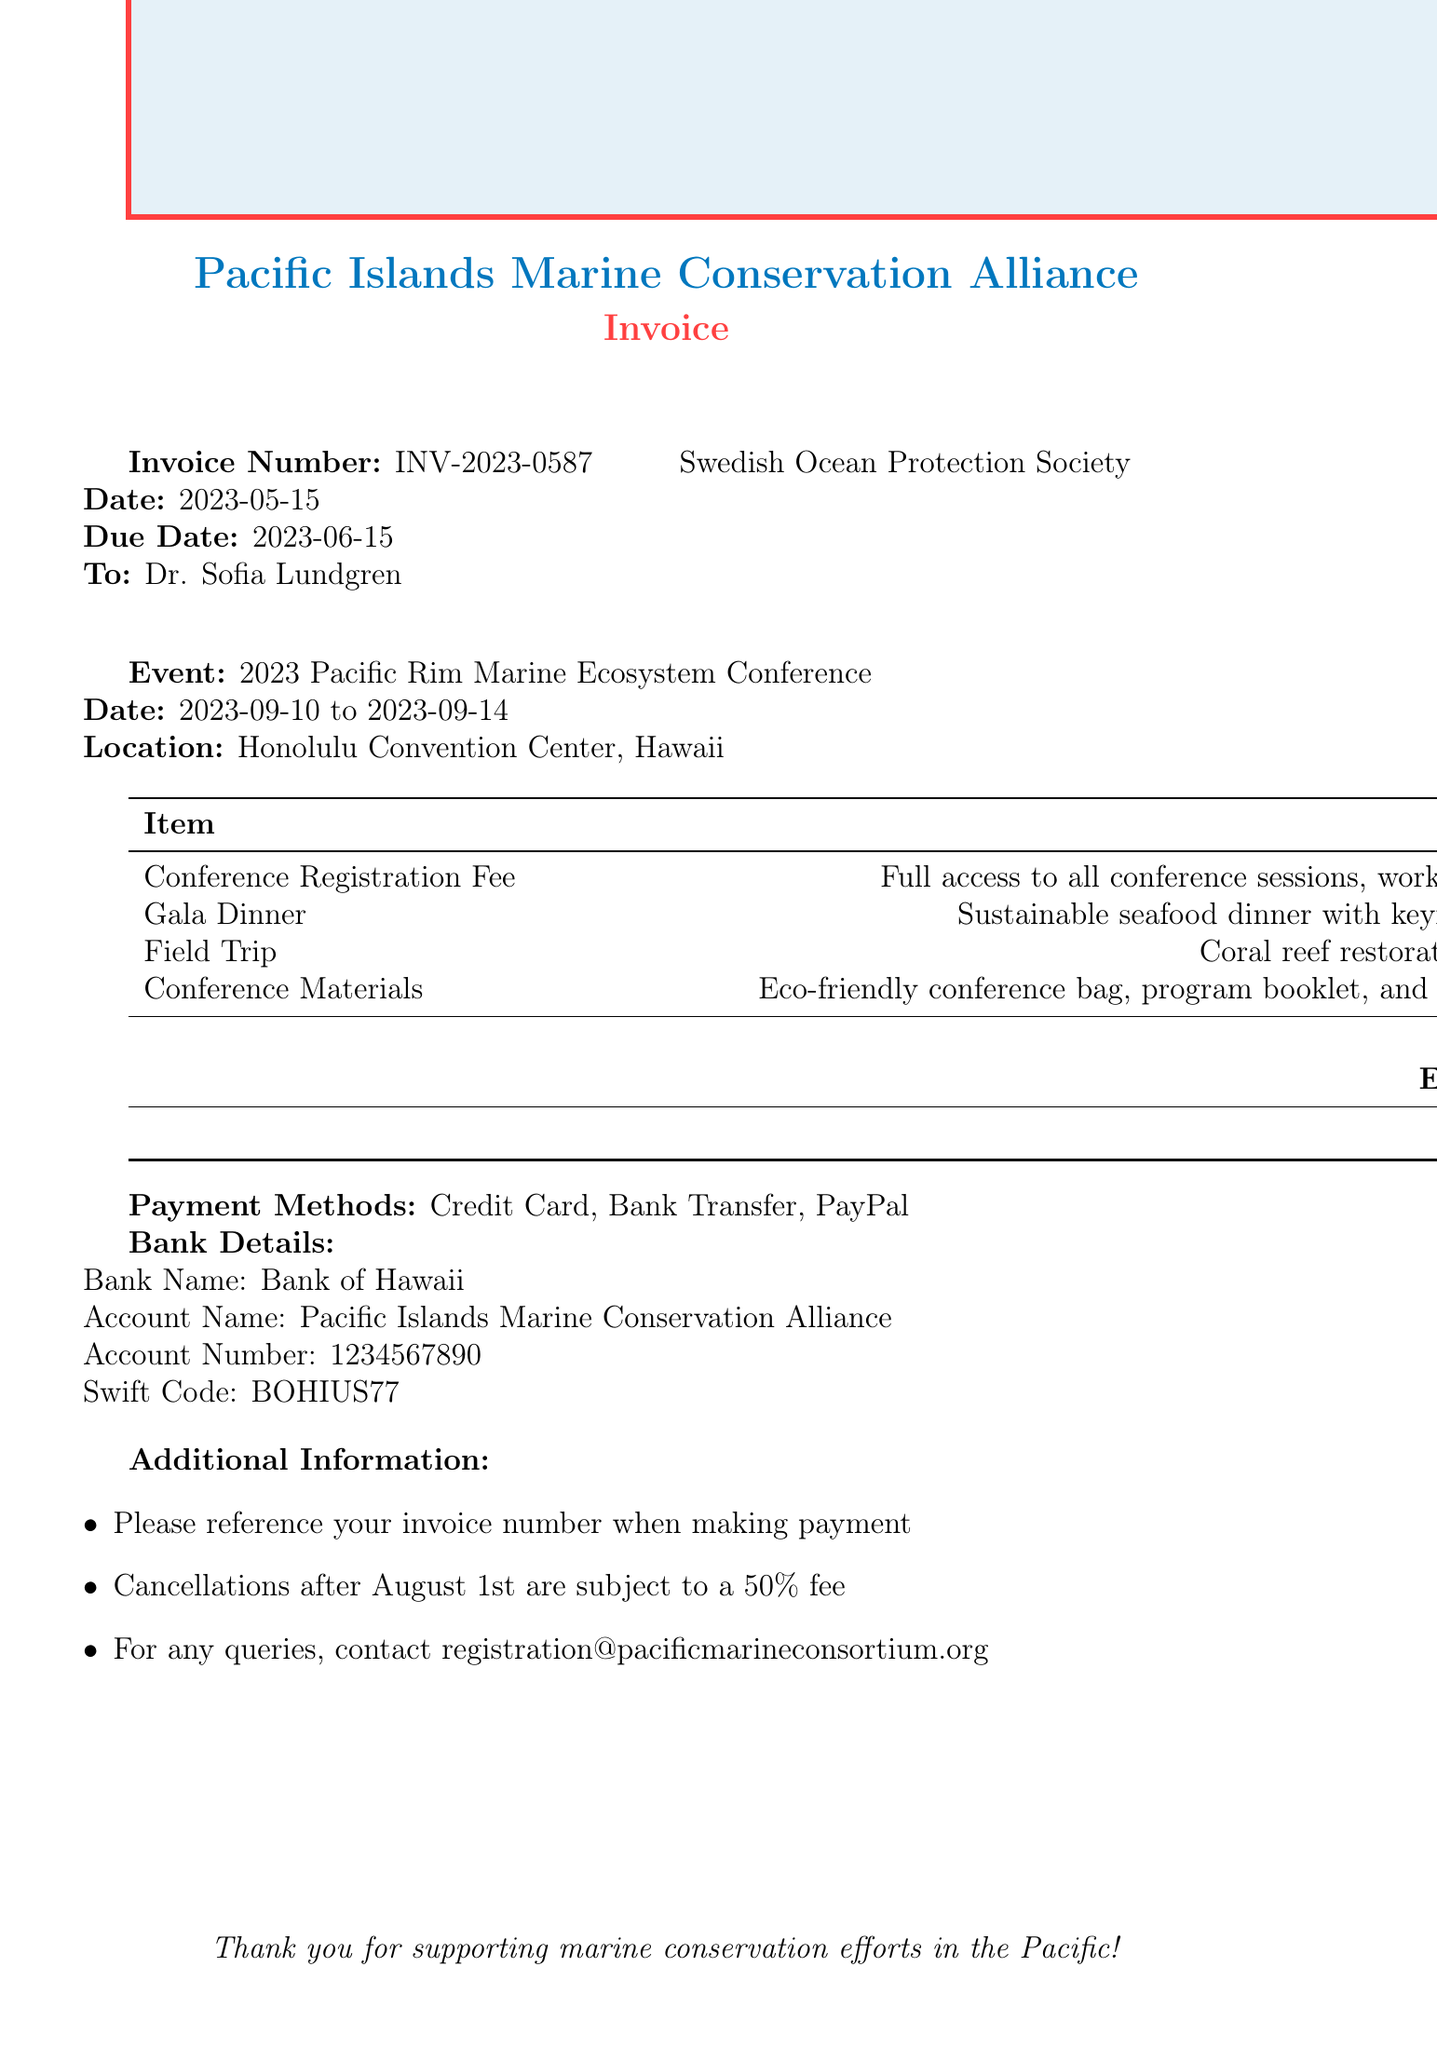What is the invoice number? The invoice number is a unique identifier for the transaction in the document.
Answer: INV-2023-0587 What is the event location? The event location specifies where the conference will take place.
Answer: Honolulu Convention Center, Hawaii What is the subtotal amount? The subtotal amount sums up all charges before any discounts are applied.
Answer: 1005.00 What is the early bird discount percentage? The early bird discount percentage indicates the reduction applied for early registration.
Answer: 15% What is the total amount due? The total amount due is the final amount to be paid after applying discounts.
Answer: 854.25 How many days does the conference span? The duration of the conference is determined by the start and end dates provided.
Answer: 5 days What is the payment method that is not accepted? Identifying a payment method that is not mentioned in the document could provide useful information.
Answer: None (all listed methods are accepted) What is the cancellation policy mentioned? The cancellation policy outlines the fees associated with late cancellations.
Answer: 50% fee after August 1st Who is the keynote speaker at the gala dinner? The name of the keynote speaker is important as it may draw attendees to the event.
Answer: Dr. Sylvia Earle 